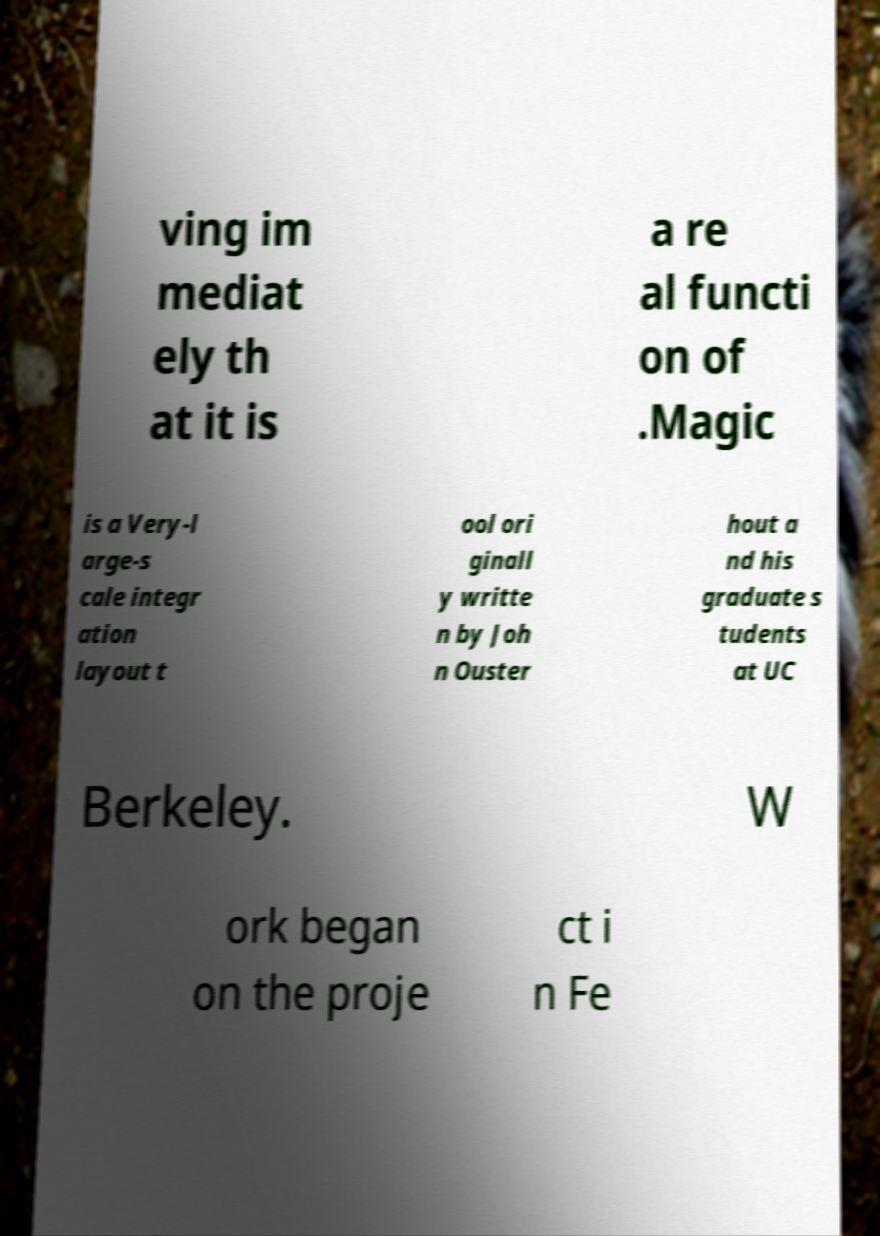Could you assist in decoding the text presented in this image and type it out clearly? ving im mediat ely th at it is a re al functi on of .Magic is a Very-l arge-s cale integr ation layout t ool ori ginall y writte n by Joh n Ouster hout a nd his graduate s tudents at UC Berkeley. W ork began on the proje ct i n Fe 